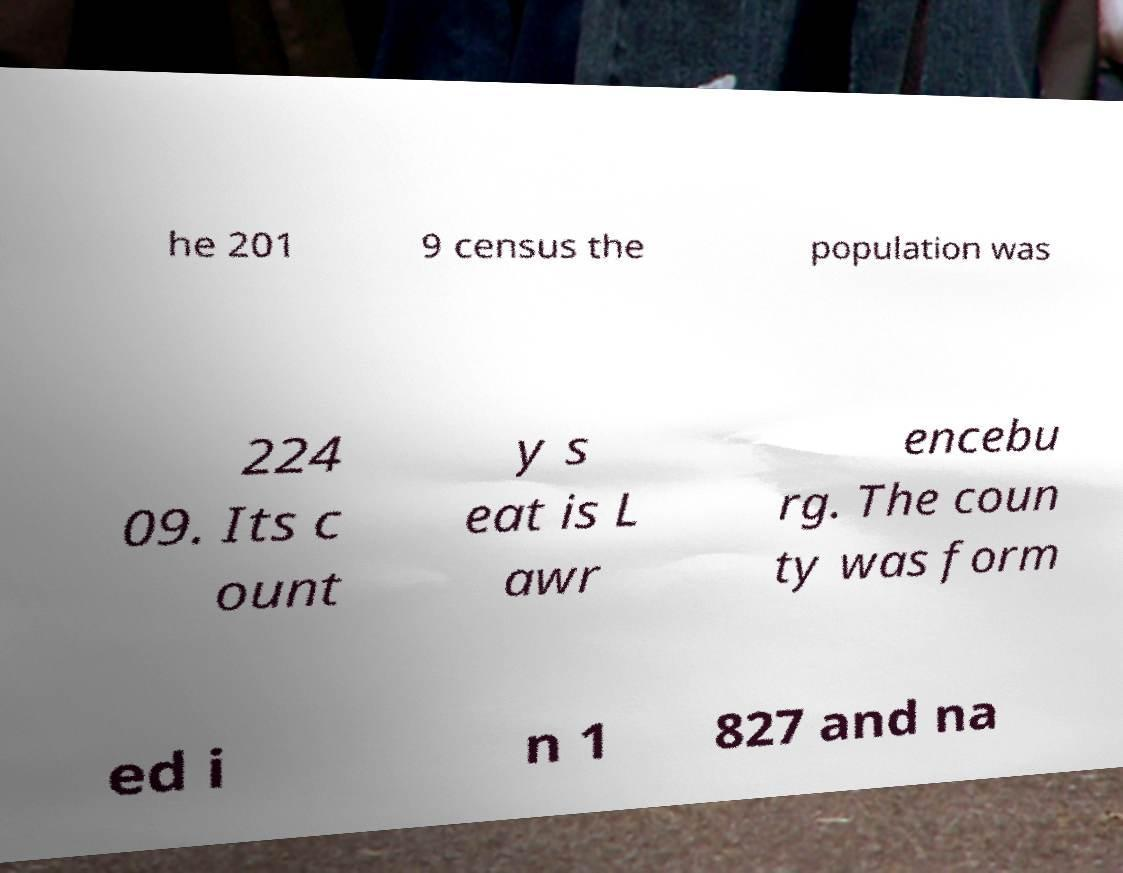For documentation purposes, I need the text within this image transcribed. Could you provide that? he 201 9 census the population was 224 09. Its c ount y s eat is L awr encebu rg. The coun ty was form ed i n 1 827 and na 